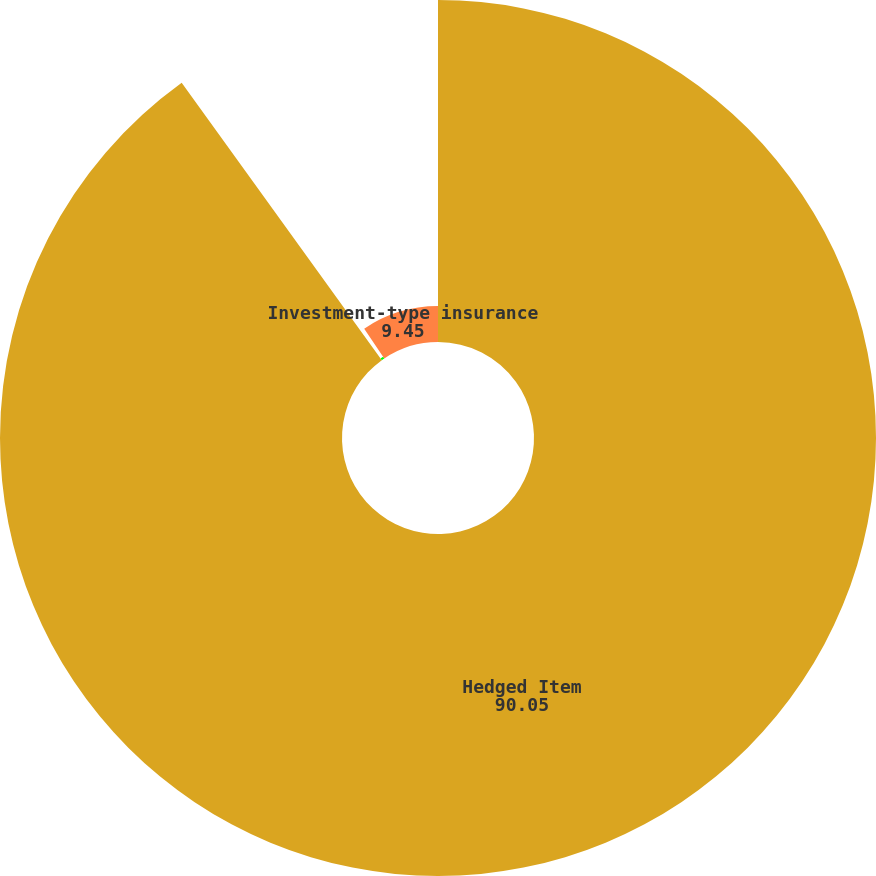<chart> <loc_0><loc_0><loc_500><loc_500><pie_chart><fcel>Hedged Item<fcel>Fixed maturities<fcel>Investment-type insurance<nl><fcel>90.05%<fcel>0.5%<fcel>9.45%<nl></chart> 